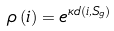<formula> <loc_0><loc_0><loc_500><loc_500>\rho \left ( i \right ) = e ^ { \kappa d ( i , S _ { g } ) }</formula> 